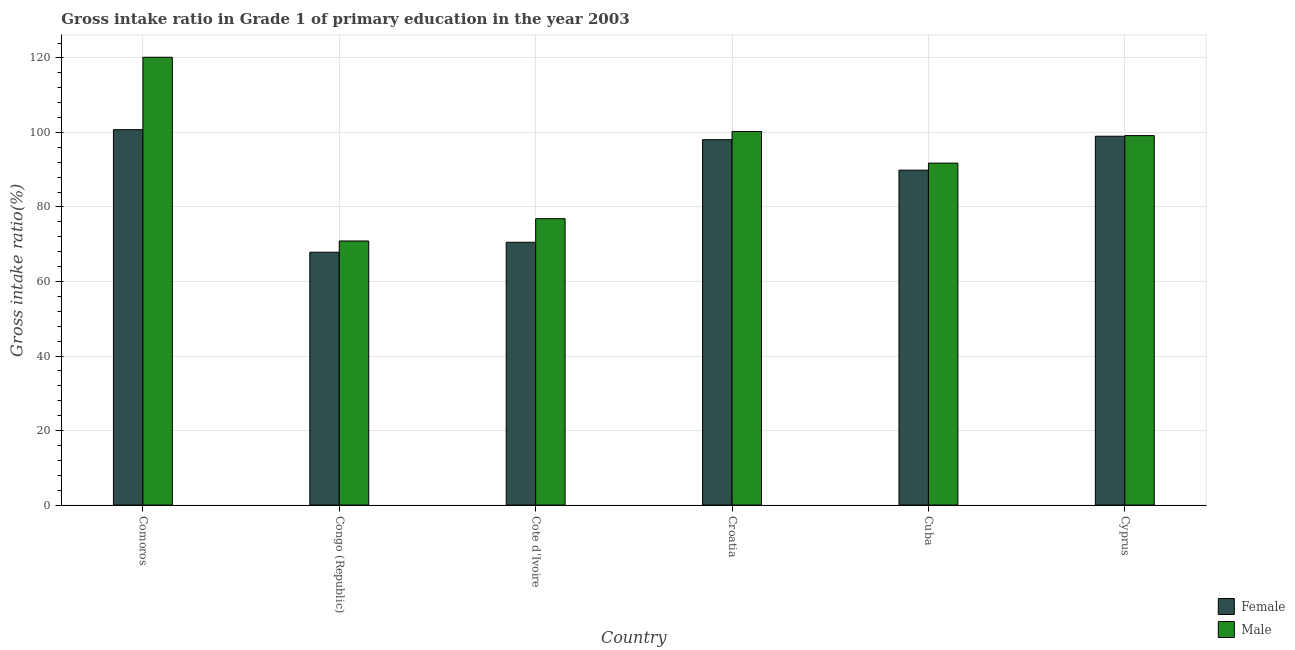How many groups of bars are there?
Offer a terse response. 6. What is the label of the 5th group of bars from the left?
Your answer should be compact. Cuba. What is the gross intake ratio(male) in Comoros?
Give a very brief answer. 120.17. Across all countries, what is the maximum gross intake ratio(male)?
Offer a very short reply. 120.17. Across all countries, what is the minimum gross intake ratio(female)?
Provide a succinct answer. 67.85. In which country was the gross intake ratio(female) maximum?
Ensure brevity in your answer.  Comoros. In which country was the gross intake ratio(female) minimum?
Provide a succinct answer. Congo (Republic). What is the total gross intake ratio(female) in the graph?
Your answer should be very brief. 526.03. What is the difference between the gross intake ratio(female) in Croatia and that in Cuba?
Keep it short and to the point. 8.19. What is the difference between the gross intake ratio(female) in Croatia and the gross intake ratio(male) in Cote d'Ivoire?
Provide a short and direct response. 21.2. What is the average gross intake ratio(female) per country?
Provide a succinct answer. 87.67. What is the difference between the gross intake ratio(female) and gross intake ratio(male) in Congo (Republic)?
Offer a terse response. -3.02. In how many countries, is the gross intake ratio(female) greater than 48 %?
Keep it short and to the point. 6. What is the ratio of the gross intake ratio(male) in Congo (Republic) to that in Cyprus?
Your answer should be very brief. 0.71. Is the gross intake ratio(male) in Cote d'Ivoire less than that in Cuba?
Give a very brief answer. Yes. What is the difference between the highest and the second highest gross intake ratio(female)?
Keep it short and to the point. 1.76. What is the difference between the highest and the lowest gross intake ratio(male)?
Your answer should be very brief. 49.3. Is the sum of the gross intake ratio(female) in Croatia and Cyprus greater than the maximum gross intake ratio(male) across all countries?
Provide a succinct answer. Yes. Are all the bars in the graph horizontal?
Offer a terse response. No. How many countries are there in the graph?
Make the answer very short. 6. What is the difference between two consecutive major ticks on the Y-axis?
Give a very brief answer. 20. Are the values on the major ticks of Y-axis written in scientific E-notation?
Make the answer very short. No. How are the legend labels stacked?
Make the answer very short. Vertical. What is the title of the graph?
Keep it short and to the point. Gross intake ratio in Grade 1 of primary education in the year 2003. Does "Under-five" appear as one of the legend labels in the graph?
Keep it short and to the point. No. What is the label or title of the X-axis?
Provide a short and direct response. Country. What is the label or title of the Y-axis?
Your answer should be compact. Gross intake ratio(%). What is the Gross intake ratio(%) in Female in Comoros?
Provide a succinct answer. 100.74. What is the Gross intake ratio(%) in Male in Comoros?
Your answer should be compact. 120.17. What is the Gross intake ratio(%) of Female in Congo (Republic)?
Offer a very short reply. 67.85. What is the Gross intake ratio(%) of Male in Congo (Republic)?
Ensure brevity in your answer.  70.87. What is the Gross intake ratio(%) in Female in Cote d'Ivoire?
Your answer should be compact. 70.52. What is the Gross intake ratio(%) of Male in Cote d'Ivoire?
Your answer should be compact. 76.86. What is the Gross intake ratio(%) of Female in Croatia?
Offer a terse response. 98.06. What is the Gross intake ratio(%) of Male in Croatia?
Offer a very short reply. 100.25. What is the Gross intake ratio(%) of Female in Cuba?
Offer a terse response. 89.87. What is the Gross intake ratio(%) in Male in Cuba?
Ensure brevity in your answer.  91.77. What is the Gross intake ratio(%) of Female in Cyprus?
Provide a short and direct response. 98.98. What is the Gross intake ratio(%) in Male in Cyprus?
Your response must be concise. 99.15. Across all countries, what is the maximum Gross intake ratio(%) of Female?
Keep it short and to the point. 100.74. Across all countries, what is the maximum Gross intake ratio(%) of Male?
Your answer should be very brief. 120.17. Across all countries, what is the minimum Gross intake ratio(%) of Female?
Offer a very short reply. 67.85. Across all countries, what is the minimum Gross intake ratio(%) of Male?
Provide a succinct answer. 70.87. What is the total Gross intake ratio(%) of Female in the graph?
Your answer should be very brief. 526.03. What is the total Gross intake ratio(%) of Male in the graph?
Ensure brevity in your answer.  559.07. What is the difference between the Gross intake ratio(%) of Female in Comoros and that in Congo (Republic)?
Make the answer very short. 32.89. What is the difference between the Gross intake ratio(%) in Male in Comoros and that in Congo (Republic)?
Provide a succinct answer. 49.3. What is the difference between the Gross intake ratio(%) in Female in Comoros and that in Cote d'Ivoire?
Offer a terse response. 30.22. What is the difference between the Gross intake ratio(%) in Male in Comoros and that in Cote d'Ivoire?
Keep it short and to the point. 43.32. What is the difference between the Gross intake ratio(%) in Female in Comoros and that in Croatia?
Your response must be concise. 2.68. What is the difference between the Gross intake ratio(%) in Male in Comoros and that in Croatia?
Give a very brief answer. 19.92. What is the difference between the Gross intake ratio(%) of Female in Comoros and that in Cuba?
Your response must be concise. 10.87. What is the difference between the Gross intake ratio(%) of Male in Comoros and that in Cuba?
Your answer should be very brief. 28.4. What is the difference between the Gross intake ratio(%) in Female in Comoros and that in Cyprus?
Provide a short and direct response. 1.76. What is the difference between the Gross intake ratio(%) in Male in Comoros and that in Cyprus?
Make the answer very short. 21.03. What is the difference between the Gross intake ratio(%) in Female in Congo (Republic) and that in Cote d'Ivoire?
Ensure brevity in your answer.  -2.67. What is the difference between the Gross intake ratio(%) in Male in Congo (Republic) and that in Cote d'Ivoire?
Offer a very short reply. -5.98. What is the difference between the Gross intake ratio(%) of Female in Congo (Republic) and that in Croatia?
Your answer should be compact. -30.21. What is the difference between the Gross intake ratio(%) in Male in Congo (Republic) and that in Croatia?
Your answer should be compact. -29.38. What is the difference between the Gross intake ratio(%) of Female in Congo (Republic) and that in Cuba?
Provide a succinct answer. -22.02. What is the difference between the Gross intake ratio(%) of Male in Congo (Republic) and that in Cuba?
Offer a terse response. -20.9. What is the difference between the Gross intake ratio(%) in Female in Congo (Republic) and that in Cyprus?
Provide a succinct answer. -31.12. What is the difference between the Gross intake ratio(%) of Male in Congo (Republic) and that in Cyprus?
Keep it short and to the point. -28.27. What is the difference between the Gross intake ratio(%) in Female in Cote d'Ivoire and that in Croatia?
Keep it short and to the point. -27.54. What is the difference between the Gross intake ratio(%) of Male in Cote d'Ivoire and that in Croatia?
Offer a terse response. -23.4. What is the difference between the Gross intake ratio(%) in Female in Cote d'Ivoire and that in Cuba?
Provide a succinct answer. -19.35. What is the difference between the Gross intake ratio(%) of Male in Cote d'Ivoire and that in Cuba?
Give a very brief answer. -14.91. What is the difference between the Gross intake ratio(%) of Female in Cote d'Ivoire and that in Cyprus?
Give a very brief answer. -28.45. What is the difference between the Gross intake ratio(%) in Male in Cote d'Ivoire and that in Cyprus?
Keep it short and to the point. -22.29. What is the difference between the Gross intake ratio(%) of Female in Croatia and that in Cuba?
Offer a terse response. 8.19. What is the difference between the Gross intake ratio(%) in Male in Croatia and that in Cuba?
Your response must be concise. 8.48. What is the difference between the Gross intake ratio(%) of Female in Croatia and that in Cyprus?
Offer a very short reply. -0.92. What is the difference between the Gross intake ratio(%) of Male in Croatia and that in Cyprus?
Your response must be concise. 1.1. What is the difference between the Gross intake ratio(%) in Female in Cuba and that in Cyprus?
Offer a terse response. -9.1. What is the difference between the Gross intake ratio(%) in Male in Cuba and that in Cyprus?
Provide a succinct answer. -7.38. What is the difference between the Gross intake ratio(%) in Female in Comoros and the Gross intake ratio(%) in Male in Congo (Republic)?
Your answer should be compact. 29.87. What is the difference between the Gross intake ratio(%) in Female in Comoros and the Gross intake ratio(%) in Male in Cote d'Ivoire?
Make the answer very short. 23.88. What is the difference between the Gross intake ratio(%) of Female in Comoros and the Gross intake ratio(%) of Male in Croatia?
Give a very brief answer. 0.49. What is the difference between the Gross intake ratio(%) in Female in Comoros and the Gross intake ratio(%) in Male in Cuba?
Your answer should be very brief. 8.97. What is the difference between the Gross intake ratio(%) of Female in Comoros and the Gross intake ratio(%) of Male in Cyprus?
Offer a terse response. 1.59. What is the difference between the Gross intake ratio(%) in Female in Congo (Republic) and the Gross intake ratio(%) in Male in Cote d'Ivoire?
Make the answer very short. -9. What is the difference between the Gross intake ratio(%) of Female in Congo (Republic) and the Gross intake ratio(%) of Male in Croatia?
Make the answer very short. -32.4. What is the difference between the Gross intake ratio(%) of Female in Congo (Republic) and the Gross intake ratio(%) of Male in Cuba?
Offer a terse response. -23.92. What is the difference between the Gross intake ratio(%) in Female in Congo (Republic) and the Gross intake ratio(%) in Male in Cyprus?
Your answer should be very brief. -31.29. What is the difference between the Gross intake ratio(%) of Female in Cote d'Ivoire and the Gross intake ratio(%) of Male in Croatia?
Provide a succinct answer. -29.73. What is the difference between the Gross intake ratio(%) of Female in Cote d'Ivoire and the Gross intake ratio(%) of Male in Cuba?
Give a very brief answer. -21.25. What is the difference between the Gross intake ratio(%) in Female in Cote d'Ivoire and the Gross intake ratio(%) in Male in Cyprus?
Offer a very short reply. -28.62. What is the difference between the Gross intake ratio(%) in Female in Croatia and the Gross intake ratio(%) in Male in Cuba?
Offer a very short reply. 6.29. What is the difference between the Gross intake ratio(%) of Female in Croatia and the Gross intake ratio(%) of Male in Cyprus?
Your answer should be compact. -1.09. What is the difference between the Gross intake ratio(%) in Female in Cuba and the Gross intake ratio(%) in Male in Cyprus?
Your answer should be compact. -9.27. What is the average Gross intake ratio(%) of Female per country?
Keep it short and to the point. 87.67. What is the average Gross intake ratio(%) in Male per country?
Your answer should be compact. 93.18. What is the difference between the Gross intake ratio(%) of Female and Gross intake ratio(%) of Male in Comoros?
Provide a succinct answer. -19.43. What is the difference between the Gross intake ratio(%) in Female and Gross intake ratio(%) in Male in Congo (Republic)?
Provide a short and direct response. -3.02. What is the difference between the Gross intake ratio(%) of Female and Gross intake ratio(%) of Male in Cote d'Ivoire?
Your answer should be very brief. -6.33. What is the difference between the Gross intake ratio(%) of Female and Gross intake ratio(%) of Male in Croatia?
Your response must be concise. -2.19. What is the difference between the Gross intake ratio(%) of Female and Gross intake ratio(%) of Male in Cuba?
Provide a succinct answer. -1.9. What is the difference between the Gross intake ratio(%) of Female and Gross intake ratio(%) of Male in Cyprus?
Make the answer very short. -0.17. What is the ratio of the Gross intake ratio(%) in Female in Comoros to that in Congo (Republic)?
Your answer should be compact. 1.48. What is the ratio of the Gross intake ratio(%) of Male in Comoros to that in Congo (Republic)?
Give a very brief answer. 1.7. What is the ratio of the Gross intake ratio(%) in Female in Comoros to that in Cote d'Ivoire?
Provide a succinct answer. 1.43. What is the ratio of the Gross intake ratio(%) of Male in Comoros to that in Cote d'Ivoire?
Provide a succinct answer. 1.56. What is the ratio of the Gross intake ratio(%) in Female in Comoros to that in Croatia?
Provide a short and direct response. 1.03. What is the ratio of the Gross intake ratio(%) of Male in Comoros to that in Croatia?
Offer a terse response. 1.2. What is the ratio of the Gross intake ratio(%) of Female in Comoros to that in Cuba?
Keep it short and to the point. 1.12. What is the ratio of the Gross intake ratio(%) of Male in Comoros to that in Cuba?
Your answer should be compact. 1.31. What is the ratio of the Gross intake ratio(%) in Female in Comoros to that in Cyprus?
Provide a short and direct response. 1.02. What is the ratio of the Gross intake ratio(%) in Male in Comoros to that in Cyprus?
Your response must be concise. 1.21. What is the ratio of the Gross intake ratio(%) in Female in Congo (Republic) to that in Cote d'Ivoire?
Keep it short and to the point. 0.96. What is the ratio of the Gross intake ratio(%) of Male in Congo (Republic) to that in Cote d'Ivoire?
Keep it short and to the point. 0.92. What is the ratio of the Gross intake ratio(%) of Female in Congo (Republic) to that in Croatia?
Offer a terse response. 0.69. What is the ratio of the Gross intake ratio(%) in Male in Congo (Republic) to that in Croatia?
Your response must be concise. 0.71. What is the ratio of the Gross intake ratio(%) in Female in Congo (Republic) to that in Cuba?
Offer a terse response. 0.76. What is the ratio of the Gross intake ratio(%) in Male in Congo (Republic) to that in Cuba?
Provide a short and direct response. 0.77. What is the ratio of the Gross intake ratio(%) of Female in Congo (Republic) to that in Cyprus?
Offer a very short reply. 0.69. What is the ratio of the Gross intake ratio(%) of Male in Congo (Republic) to that in Cyprus?
Make the answer very short. 0.71. What is the ratio of the Gross intake ratio(%) of Female in Cote d'Ivoire to that in Croatia?
Provide a short and direct response. 0.72. What is the ratio of the Gross intake ratio(%) in Male in Cote d'Ivoire to that in Croatia?
Offer a very short reply. 0.77. What is the ratio of the Gross intake ratio(%) in Female in Cote d'Ivoire to that in Cuba?
Make the answer very short. 0.78. What is the ratio of the Gross intake ratio(%) of Male in Cote d'Ivoire to that in Cuba?
Your answer should be compact. 0.84. What is the ratio of the Gross intake ratio(%) in Female in Cote d'Ivoire to that in Cyprus?
Keep it short and to the point. 0.71. What is the ratio of the Gross intake ratio(%) of Male in Cote d'Ivoire to that in Cyprus?
Keep it short and to the point. 0.78. What is the ratio of the Gross intake ratio(%) in Female in Croatia to that in Cuba?
Your response must be concise. 1.09. What is the ratio of the Gross intake ratio(%) in Male in Croatia to that in Cuba?
Keep it short and to the point. 1.09. What is the ratio of the Gross intake ratio(%) of Male in Croatia to that in Cyprus?
Give a very brief answer. 1.01. What is the ratio of the Gross intake ratio(%) in Female in Cuba to that in Cyprus?
Ensure brevity in your answer.  0.91. What is the ratio of the Gross intake ratio(%) of Male in Cuba to that in Cyprus?
Your answer should be very brief. 0.93. What is the difference between the highest and the second highest Gross intake ratio(%) of Female?
Offer a terse response. 1.76. What is the difference between the highest and the second highest Gross intake ratio(%) of Male?
Give a very brief answer. 19.92. What is the difference between the highest and the lowest Gross intake ratio(%) in Female?
Your answer should be very brief. 32.89. What is the difference between the highest and the lowest Gross intake ratio(%) of Male?
Your answer should be compact. 49.3. 